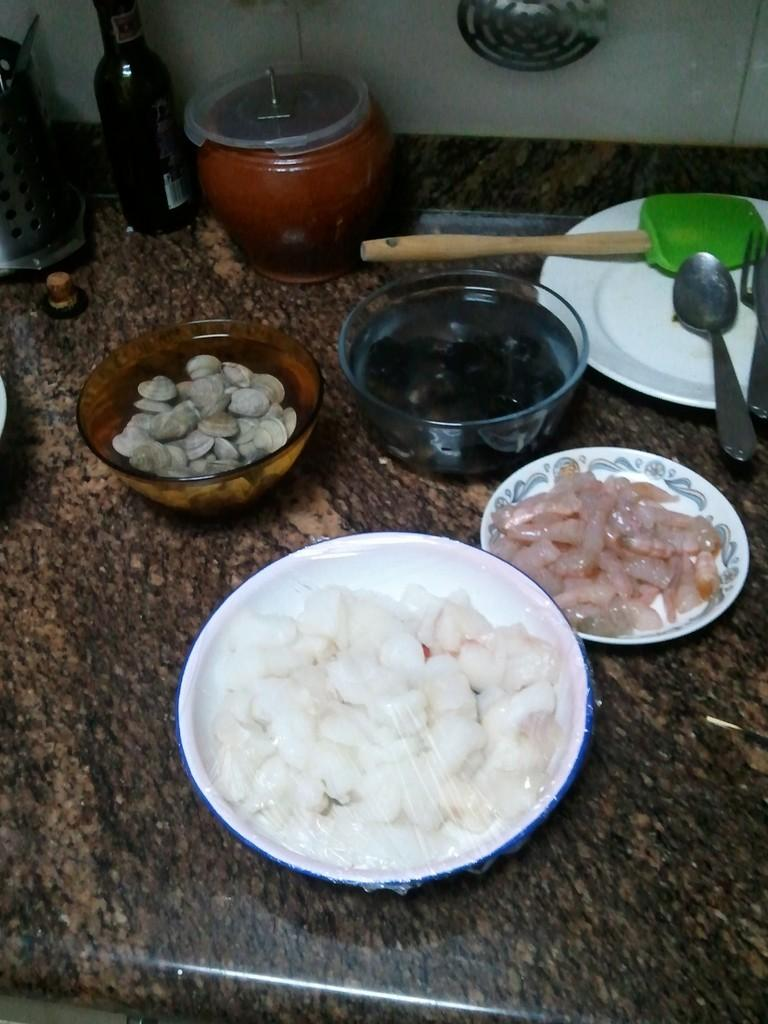What is the main object in the image? There is a bowl in the image. What other objects can be seen in the image? There are plates, a spatula, spoons, and a bottle in the image. What type of utensils are present in the image? Spoons are present in the image. What else can be found in the image? Food items are present in the image. Where might the image have been taken? The image appears to be taken in a room. What can be seen in the background of the image? There is a wall visible in the background of the image. How many cows are visible in the image? There are no cows present in the image. What activity is the chair performing in the image? There is no chair present in the image, so it cannot be performing any activity. 